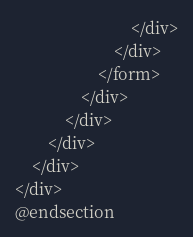<code> <loc_0><loc_0><loc_500><loc_500><_PHP_>                            </div>
                        </div>
                    </form>
                </div>
            </div>
        </div>
    </div>
</div>
@endsection
</code> 